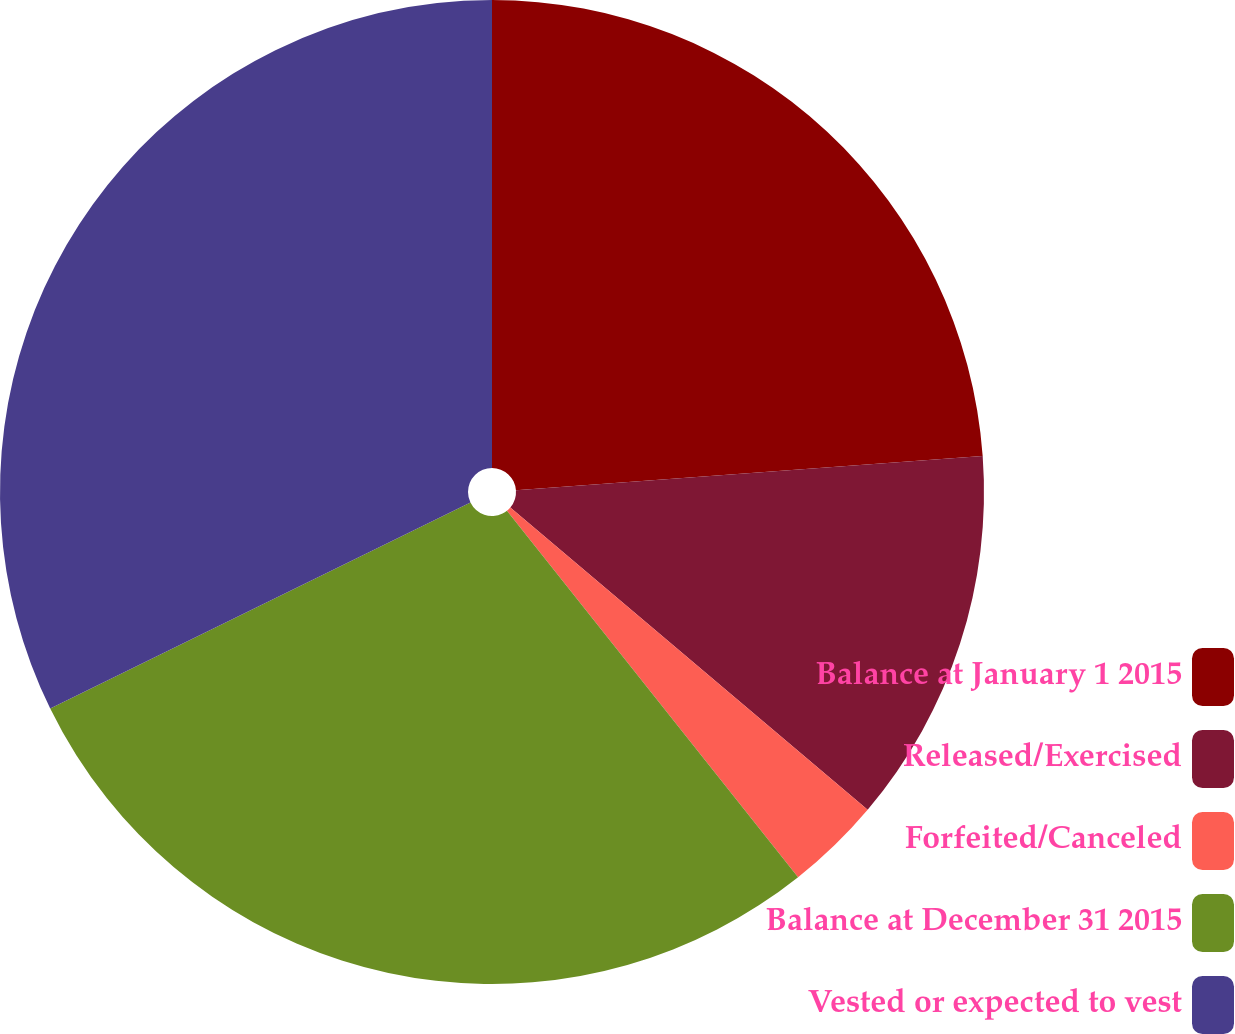Convert chart. <chart><loc_0><loc_0><loc_500><loc_500><pie_chart><fcel>Balance at January 1 2015<fcel>Released/Exercised<fcel>Forfeited/Canceled<fcel>Balance at December 31 2015<fcel>Vested or expected to vest<nl><fcel>23.83%<fcel>12.34%<fcel>3.14%<fcel>28.43%<fcel>32.25%<nl></chart> 